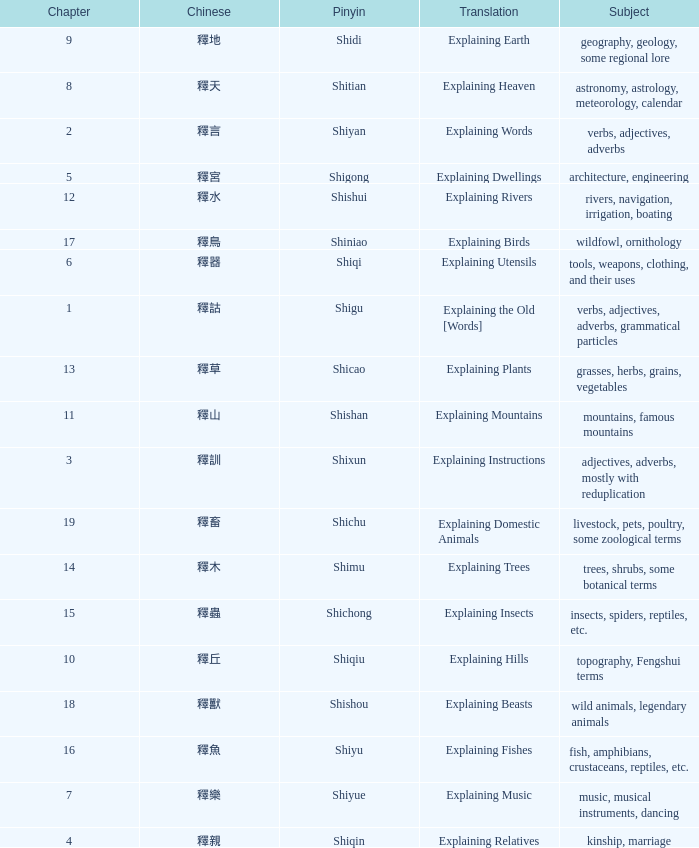Name the total number of chapter for chinese of 釋宮 1.0. Write the full table. {'header': ['Chapter', 'Chinese', 'Pinyin', 'Translation', 'Subject'], 'rows': [['9', '釋地', 'Shidi', 'Explaining Earth', 'geography, geology, some regional lore'], ['8', '釋天', 'Shitian', 'Explaining Heaven', 'astronomy, astrology, meteorology, calendar'], ['2', '釋言', 'Shiyan', 'Explaining Words', 'verbs, adjectives, adverbs'], ['5', '釋宮', 'Shigong', 'Explaining Dwellings', 'architecture, engineering'], ['12', '釋水', 'Shishui', 'Explaining Rivers', 'rivers, navigation, irrigation, boating'], ['17', '釋鳥', 'Shiniao', 'Explaining Birds', 'wildfowl, ornithology'], ['6', '釋器', 'Shiqi', 'Explaining Utensils', 'tools, weapons, clothing, and their uses'], ['1', '釋詁', 'Shigu', 'Explaining the Old [Words]', 'verbs, adjectives, adverbs, grammatical particles'], ['13', '釋草', 'Shicao', 'Explaining Plants', 'grasses, herbs, grains, vegetables'], ['11', '釋山', 'Shishan', 'Explaining Mountains', 'mountains, famous mountains'], ['3', '釋訓', 'Shixun', 'Explaining Instructions', 'adjectives, adverbs, mostly with reduplication'], ['19', '釋畜', 'Shichu', 'Explaining Domestic Animals', 'livestock, pets, poultry, some zoological terms'], ['14', '釋木', 'Shimu', 'Explaining Trees', 'trees, shrubs, some botanical terms'], ['15', '釋蟲', 'Shichong', 'Explaining Insects', 'insects, spiders, reptiles, etc.'], ['10', '釋丘', 'Shiqiu', 'Explaining Hills', 'topography, Fengshui terms'], ['18', '釋獸', 'Shishou', 'Explaining Beasts', 'wild animals, legendary animals'], ['16', '釋魚', 'Shiyu', 'Explaining Fishes', 'fish, amphibians, crustaceans, reptiles, etc.'], ['7', '釋樂', 'Shiyue', 'Explaining Music', 'music, musical instruments, dancing'], ['4', '釋親', 'Shiqin', 'Explaining Relatives', 'kinship, marriage']]} 